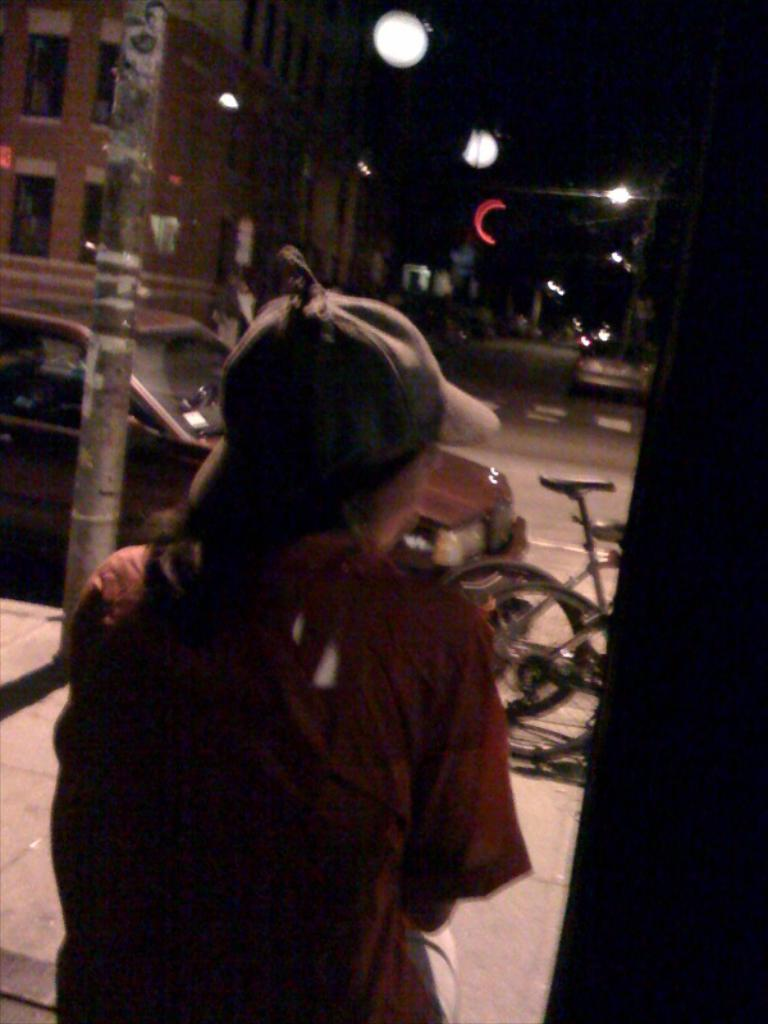What type of structures can be seen in the image? There are buildings in the image. What feature of the buildings is visible? There are windows visible in the image. What can be seen illuminating the scene? There are lights in the image. Who is present in the image? There is a person sitting in the image. What mode of transportation can be seen in the image? There are vehicles on the road in the image. What type of payment is being made by the person's grandmother in the image? There is no mention of a grandmother or any payment being made in the image. 